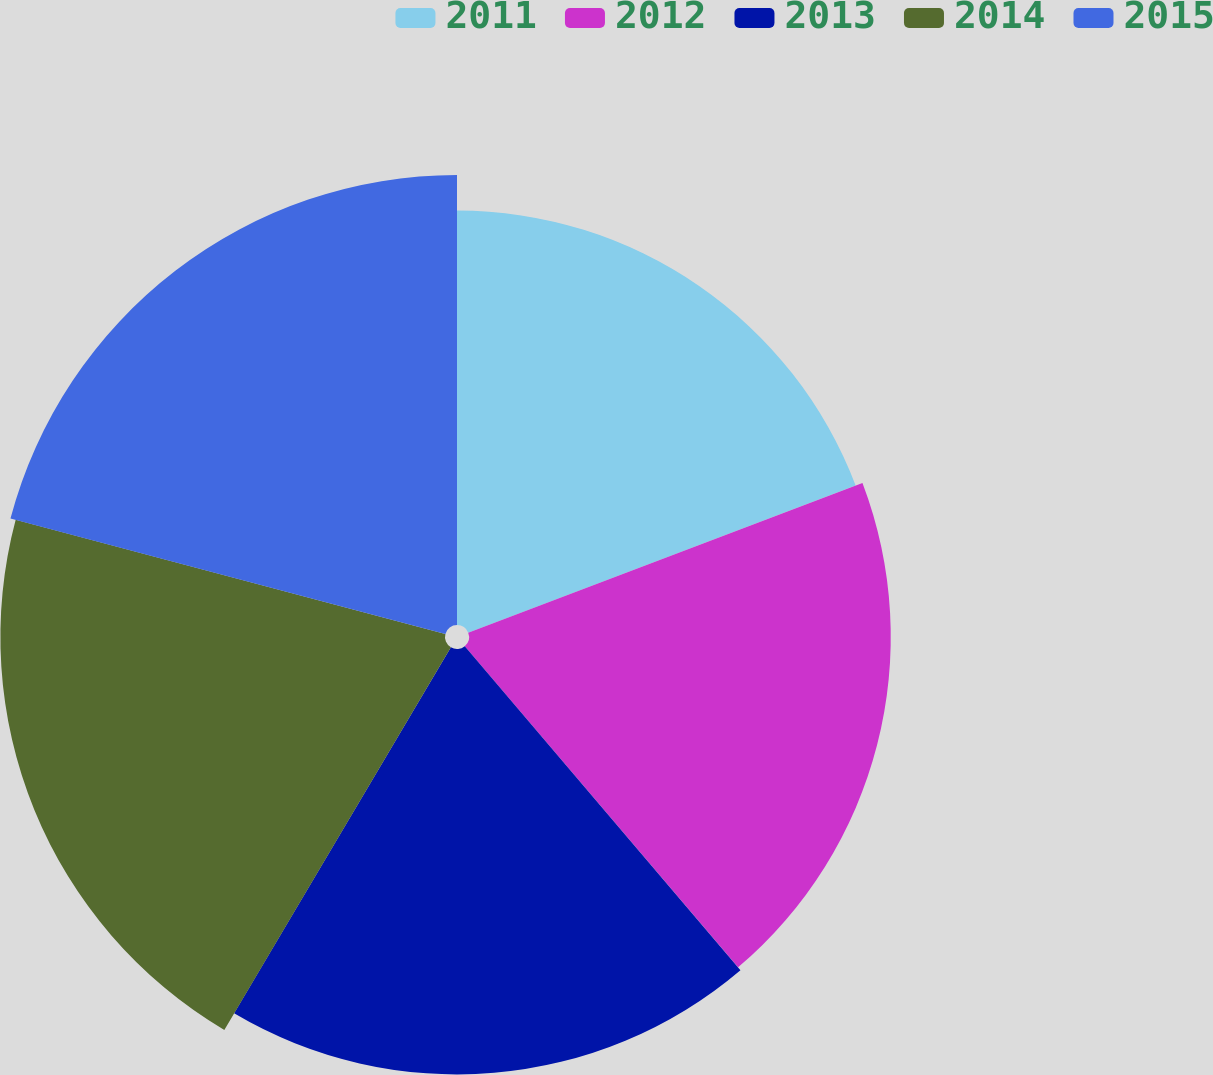<chart> <loc_0><loc_0><loc_500><loc_500><pie_chart><fcel>2011<fcel>2012<fcel>2013<fcel>2014<fcel>2015<nl><fcel>19.22%<fcel>19.56%<fcel>19.73%<fcel>20.62%<fcel>20.87%<nl></chart> 